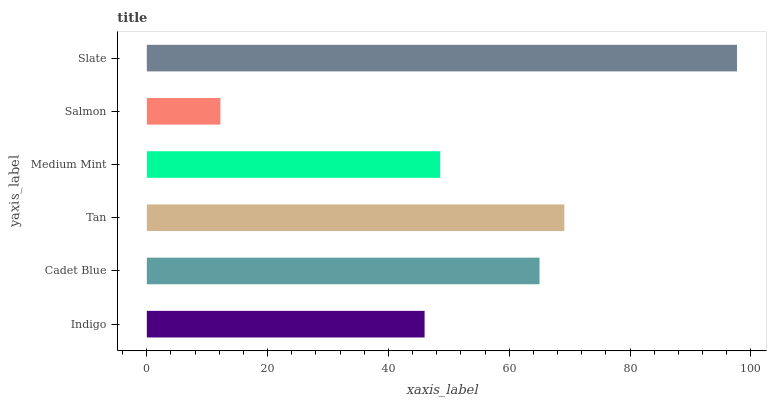Is Salmon the minimum?
Answer yes or no. Yes. Is Slate the maximum?
Answer yes or no. Yes. Is Cadet Blue the minimum?
Answer yes or no. No. Is Cadet Blue the maximum?
Answer yes or no. No. Is Cadet Blue greater than Indigo?
Answer yes or no. Yes. Is Indigo less than Cadet Blue?
Answer yes or no. Yes. Is Indigo greater than Cadet Blue?
Answer yes or no. No. Is Cadet Blue less than Indigo?
Answer yes or no. No. Is Cadet Blue the high median?
Answer yes or no. Yes. Is Medium Mint the low median?
Answer yes or no. Yes. Is Slate the high median?
Answer yes or no. No. Is Cadet Blue the low median?
Answer yes or no. No. 